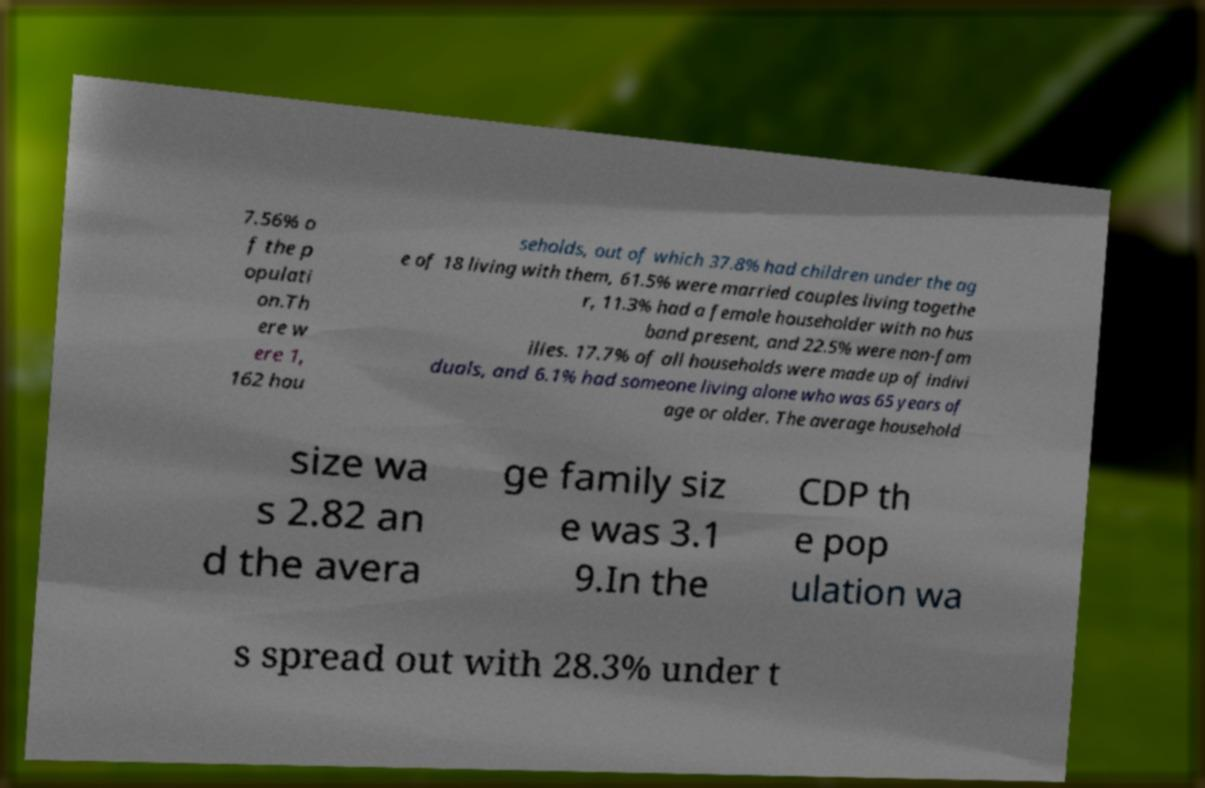For documentation purposes, I need the text within this image transcribed. Could you provide that? 7.56% o f the p opulati on.Th ere w ere 1, 162 hou seholds, out of which 37.8% had children under the ag e of 18 living with them, 61.5% were married couples living togethe r, 11.3% had a female householder with no hus band present, and 22.5% were non-fam ilies. 17.7% of all households were made up of indivi duals, and 6.1% had someone living alone who was 65 years of age or older. The average household size wa s 2.82 an d the avera ge family siz e was 3.1 9.In the CDP th e pop ulation wa s spread out with 28.3% under t 